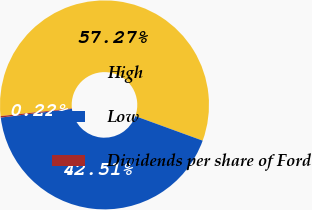<chart> <loc_0><loc_0><loc_500><loc_500><pie_chart><fcel>High<fcel>Low<fcel>Dividends per share of Ford<nl><fcel>57.27%<fcel>42.51%<fcel>0.22%<nl></chart> 